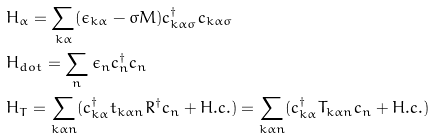Convert formula to latex. <formula><loc_0><loc_0><loc_500><loc_500>& H _ { \alpha } = \sum _ { k \alpha } ( \epsilon _ { k \alpha } - \sigma M ) c _ { k \alpha \sigma } ^ { \dag } c _ { k \alpha \sigma } \\ & H _ { d o t } = \sum _ { n } \epsilon _ { n } c _ { n } ^ { \dag } c _ { n } \\ & H _ { T } = \sum _ { k \alpha n } ( c _ { k \alpha } ^ { \dag } t _ { k \alpha n } R ^ { \dag } c _ { n } + H . c . ) = \sum _ { k \alpha n } ( c _ { k \alpha } ^ { \dag } T _ { k \alpha n } c _ { n } + H . c . )</formula> 